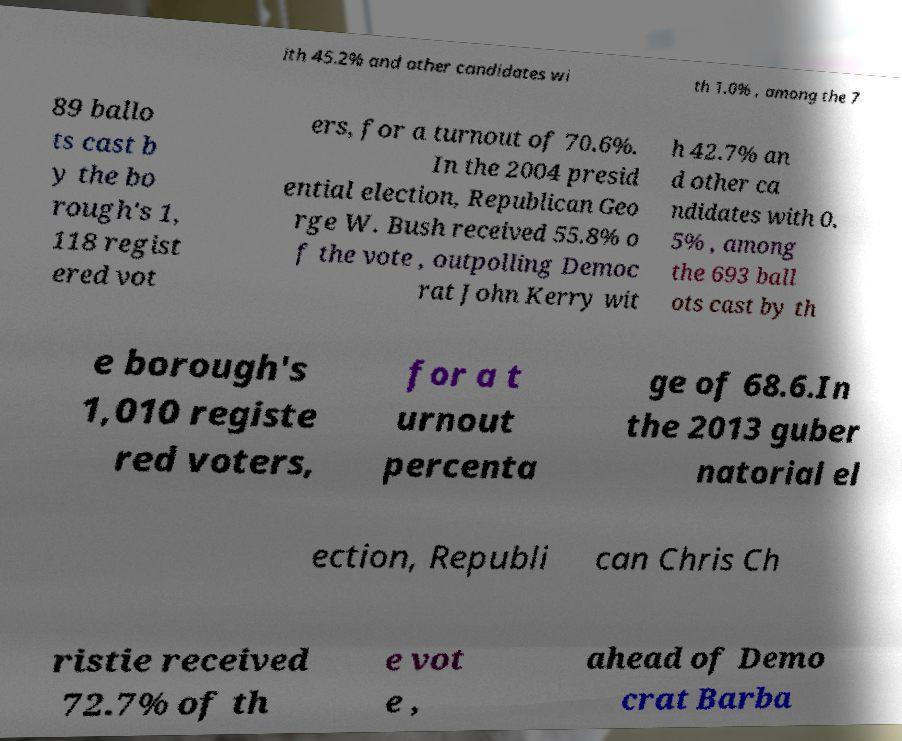What messages or text are displayed in this image? I need them in a readable, typed format. ith 45.2% and other candidates wi th 1.0% , among the 7 89 ballo ts cast b y the bo rough's 1, 118 regist ered vot ers, for a turnout of 70.6%. In the 2004 presid ential election, Republican Geo rge W. Bush received 55.8% o f the vote , outpolling Democ rat John Kerry wit h 42.7% an d other ca ndidates with 0. 5% , among the 693 ball ots cast by th e borough's 1,010 registe red voters, for a t urnout percenta ge of 68.6.In the 2013 guber natorial el ection, Republi can Chris Ch ristie received 72.7% of th e vot e , ahead of Demo crat Barba 